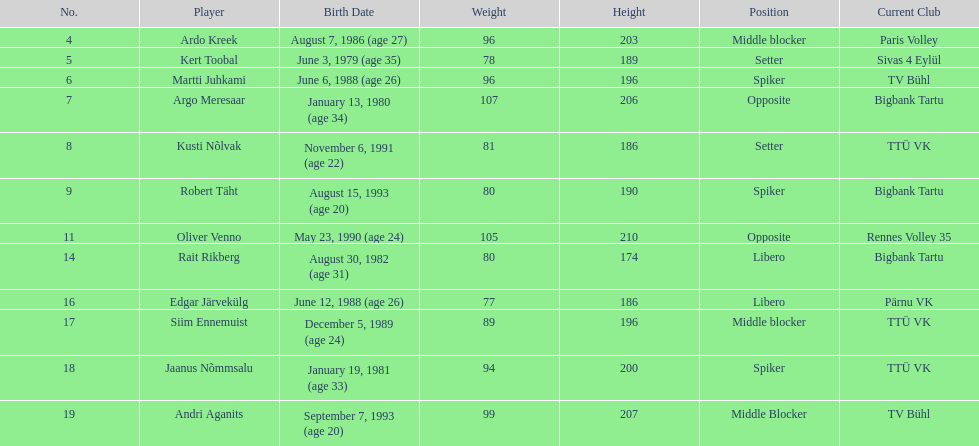Can you give me this table as a dict? {'header': ['No.', 'Player', 'Birth Date', 'Weight', 'Height', 'Position', 'Current Club'], 'rows': [['4', 'Ardo Kreek', 'August 7, 1986 (age\xa027)', '96', '203', 'Middle blocker', 'Paris Volley'], ['5', 'Kert Toobal', 'June 3, 1979 (age\xa035)', '78', '189', 'Setter', 'Sivas 4 Eylül'], ['6', 'Martti Juhkami', 'June 6, 1988 (age\xa026)', '96', '196', 'Spiker', 'TV Bühl'], ['7', 'Argo Meresaar', 'January 13, 1980 (age\xa034)', '107', '206', 'Opposite', 'Bigbank Tartu'], ['8', 'Kusti Nõlvak', 'November 6, 1991 (age\xa022)', '81', '186', 'Setter', 'TTÜ VK'], ['9', 'Robert Täht', 'August 15, 1993 (age\xa020)', '80', '190', 'Spiker', 'Bigbank Tartu'], ['11', 'Oliver Venno', 'May 23, 1990 (age\xa024)', '105', '210', 'Opposite', 'Rennes Volley 35'], ['14', 'Rait Rikberg', 'August 30, 1982 (age\xa031)', '80', '174', 'Libero', 'Bigbank Tartu'], ['16', 'Edgar Järvekülg', 'June 12, 1988 (age\xa026)', '77', '186', 'Libero', 'Pärnu VK'], ['17', 'Siim Ennemuist', 'December 5, 1989 (age\xa024)', '89', '196', 'Middle blocker', 'TTÜ VK'], ['18', 'Jaanus Nõmmsalu', 'January 19, 1981 (age\xa033)', '94', '200', 'Spiker', 'TTÜ VK'], ['19', 'Andri Aganits', 'September 7, 1993 (age\xa020)', '99', '207', 'Middle Blocker', 'TV Bühl']]} Who is at least 25 years or older? Ardo Kreek, Kert Toobal, Martti Juhkami, Argo Meresaar, Rait Rikberg, Edgar Järvekülg, Jaanus Nõmmsalu. 